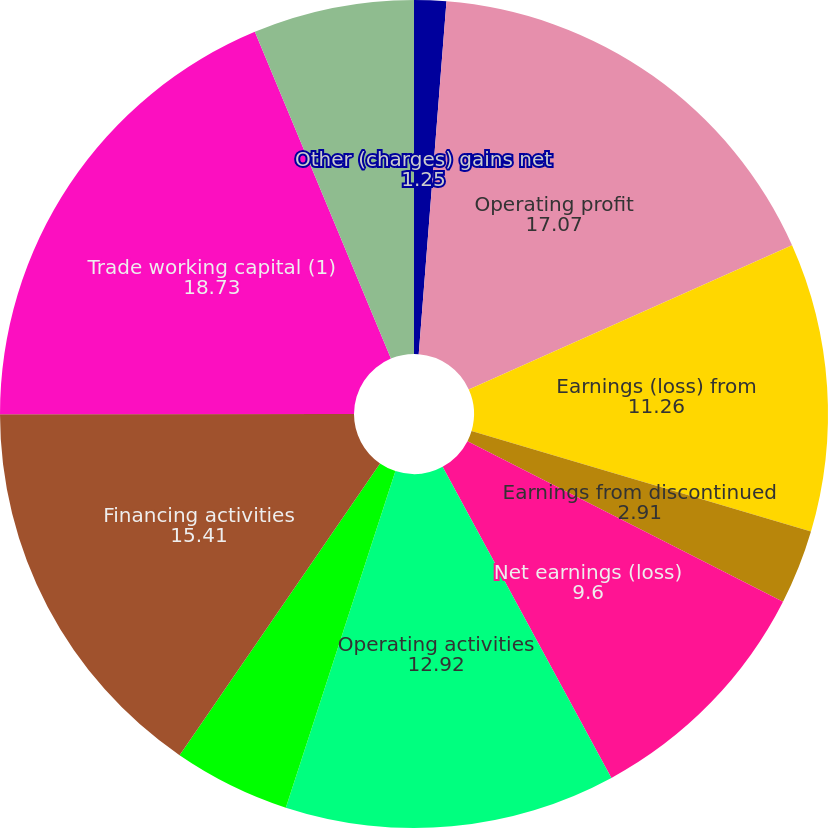<chart> <loc_0><loc_0><loc_500><loc_500><pie_chart><fcel>Other (charges) gains net<fcel>Operating profit<fcel>Earnings (loss) from<fcel>Earnings from discontinued<fcel>Net earnings (loss)<fcel>Operating activities<fcel>Investing activities<fcel>Financing activities<fcel>Trade working capital (1)<fcel>Depreciation and amortization<nl><fcel>1.25%<fcel>17.07%<fcel>11.26%<fcel>2.91%<fcel>9.6%<fcel>12.92%<fcel>4.57%<fcel>15.41%<fcel>18.73%<fcel>6.28%<nl></chart> 